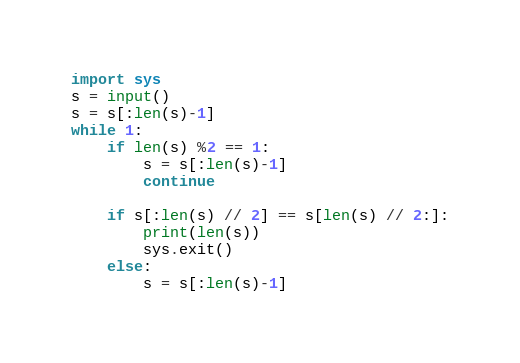<code> <loc_0><loc_0><loc_500><loc_500><_Python_>import sys
s = input()
s = s[:len(s)-1]
while 1:
    if len(s) %2 == 1:
        s = s[:len(s)-1]
        continue

    if s[:len(s) // 2] == s[len(s) // 2:]:
        print(len(s))
        sys.exit()
    else:
        s = s[:len(s)-1]</code> 